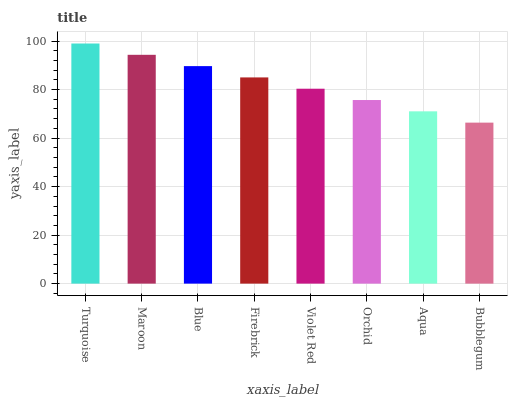Is Bubblegum the minimum?
Answer yes or no. Yes. Is Turquoise the maximum?
Answer yes or no. Yes. Is Maroon the minimum?
Answer yes or no. No. Is Maroon the maximum?
Answer yes or no. No. Is Turquoise greater than Maroon?
Answer yes or no. Yes. Is Maroon less than Turquoise?
Answer yes or no. Yes. Is Maroon greater than Turquoise?
Answer yes or no. No. Is Turquoise less than Maroon?
Answer yes or no. No. Is Firebrick the high median?
Answer yes or no. Yes. Is Violet Red the low median?
Answer yes or no. Yes. Is Turquoise the high median?
Answer yes or no. No. Is Turquoise the low median?
Answer yes or no. No. 